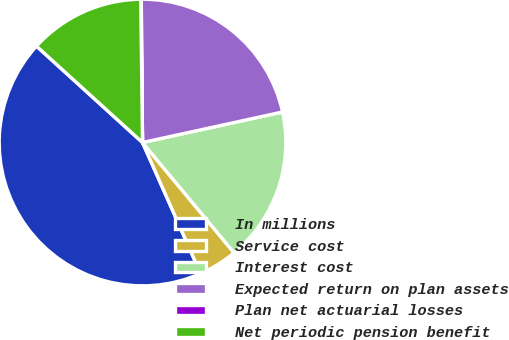Convert chart. <chart><loc_0><loc_0><loc_500><loc_500><pie_chart><fcel>In millions<fcel>Service cost<fcel>Interest cost<fcel>Expected return on plan assets<fcel>Plan net actuarial losses<fcel>Net periodic pension benefit<nl><fcel>43.38%<fcel>4.39%<fcel>17.39%<fcel>21.72%<fcel>0.06%<fcel>13.06%<nl></chart> 